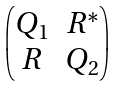<formula> <loc_0><loc_0><loc_500><loc_500>\begin{pmatrix} Q _ { 1 } & R ^ { * } \\ R & Q _ { 2 } \end{pmatrix}</formula> 